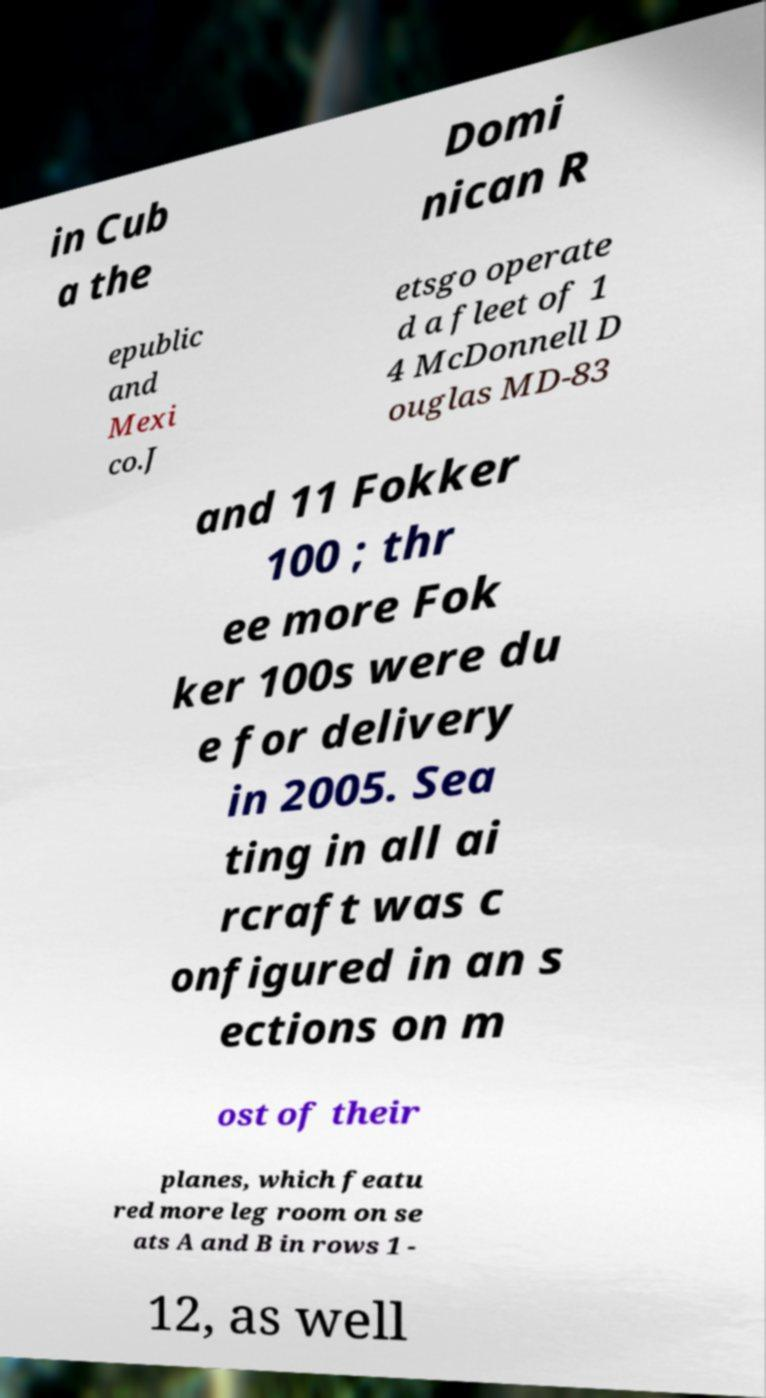For documentation purposes, I need the text within this image transcribed. Could you provide that? in Cub a the Domi nican R epublic and Mexi co.J etsgo operate d a fleet of 1 4 McDonnell D ouglas MD-83 and 11 Fokker 100 ; thr ee more Fok ker 100s were du e for delivery in 2005. Sea ting in all ai rcraft was c onfigured in an s ections on m ost of their planes, which featu red more leg room on se ats A and B in rows 1 - 12, as well 